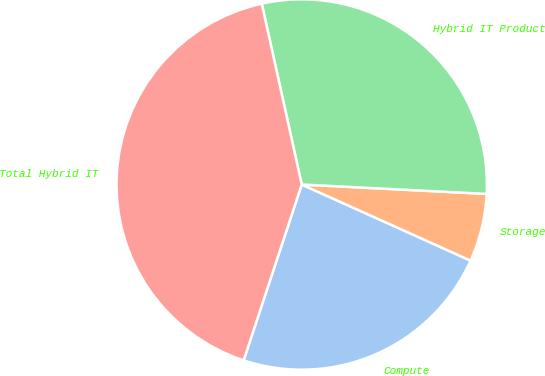Convert chart to OTSL. <chart><loc_0><loc_0><loc_500><loc_500><pie_chart><fcel>Compute<fcel>Storage<fcel>Hybrid IT Product<fcel>Total Hybrid IT<nl><fcel>23.34%<fcel>5.93%<fcel>29.27%<fcel>41.46%<nl></chart> 